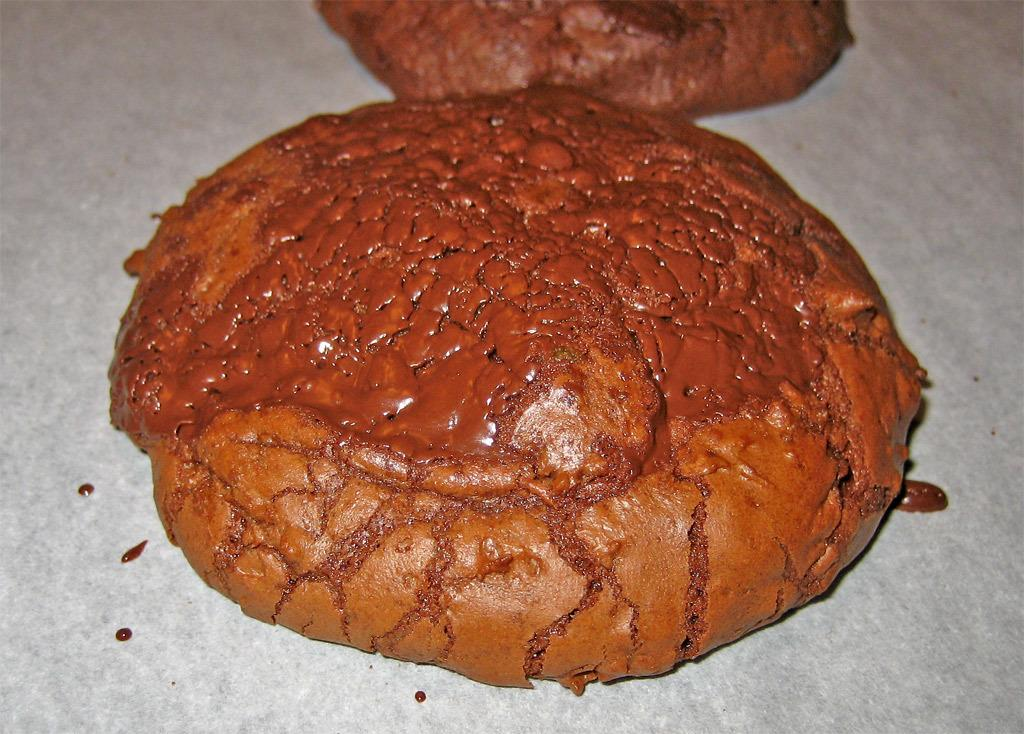What type of food items are present in the image? There are two cookies in the image. What type of clothing is the cookie wearing in the image? Cookies do not wear clothing, so this question cannot be answered based on the image. 